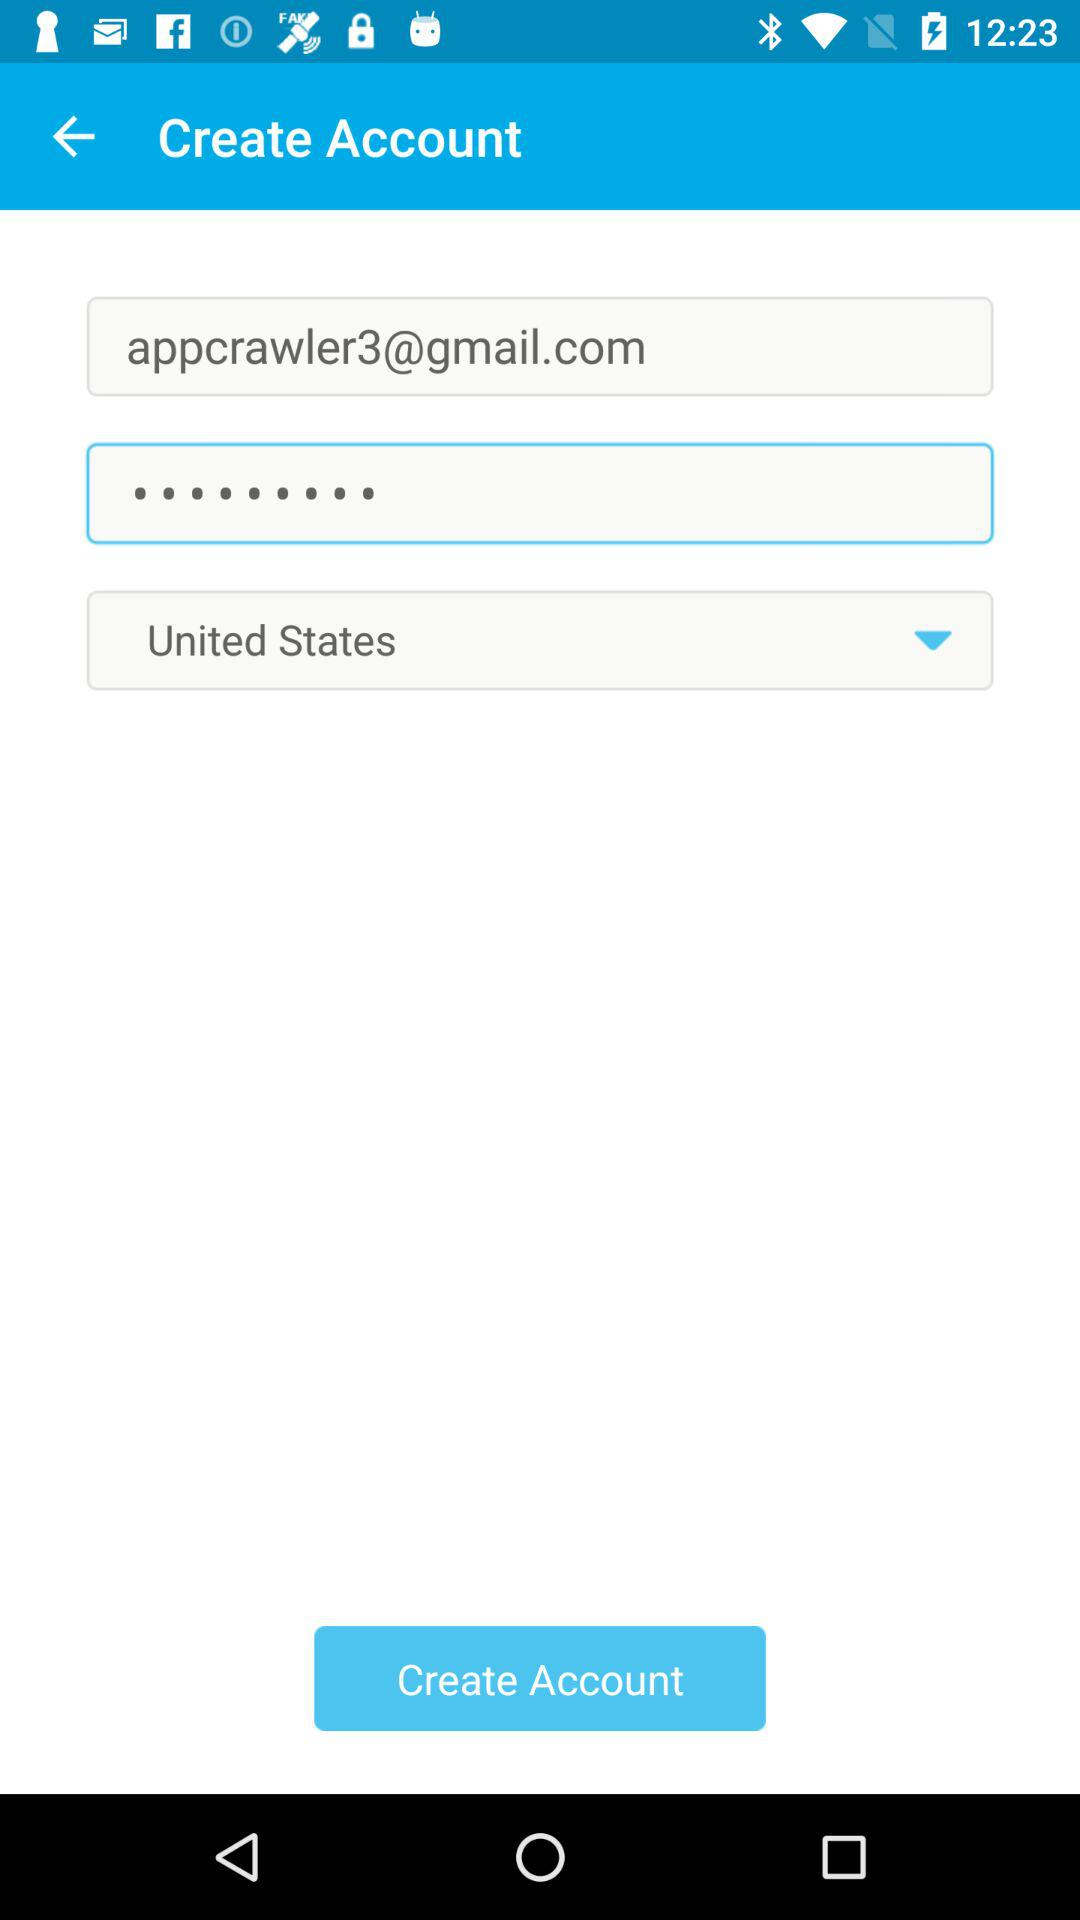What is the email address? The email address is appcrawler3@gmail.com. 